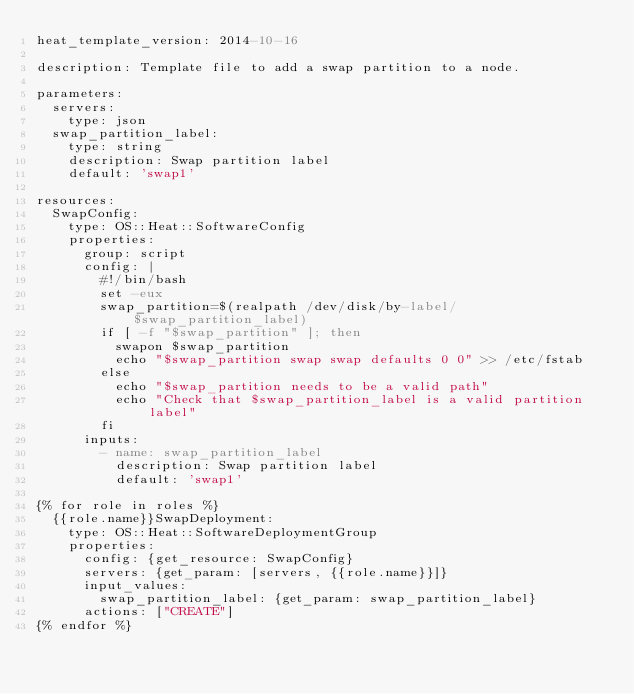Convert code to text. <code><loc_0><loc_0><loc_500><loc_500><_YAML_>heat_template_version: 2014-10-16

description: Template file to add a swap partition to a node.

parameters:
  servers:
    type: json
  swap_partition_label:
    type: string
    description: Swap partition label
    default: 'swap1'

resources:
  SwapConfig:
    type: OS::Heat::SoftwareConfig
    properties:
      group: script
      config: |
        #!/bin/bash
        set -eux
        swap_partition=$(realpath /dev/disk/by-label/$swap_partition_label)
        if [ -f "$swap_partition" ]; then
          swapon $swap_partition
          echo "$swap_partition swap swap defaults 0 0" >> /etc/fstab
        else
          echo "$swap_partition needs to be a valid path"
          echo "Check that $swap_partition_label is a valid partition label"
        fi
      inputs:
        - name: swap_partition_label
          description: Swap partition label
          default: 'swap1'

{% for role in roles %}
  {{role.name}}SwapDeployment:
    type: OS::Heat::SoftwareDeploymentGroup
    properties:
      config: {get_resource: SwapConfig}
      servers: {get_param: [servers, {{role.name}}]}
      input_values:
        swap_partition_label: {get_param: swap_partition_label}
      actions: ["CREATE"]
{% endfor %}
</code> 